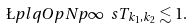Convert formula to latex. <formula><loc_0><loc_0><loc_500><loc_500>\L p l q O p N { p } { \infty } { \ s T _ { k _ { 1 } , k _ { 2 } } } \lesssim 1 .</formula> 